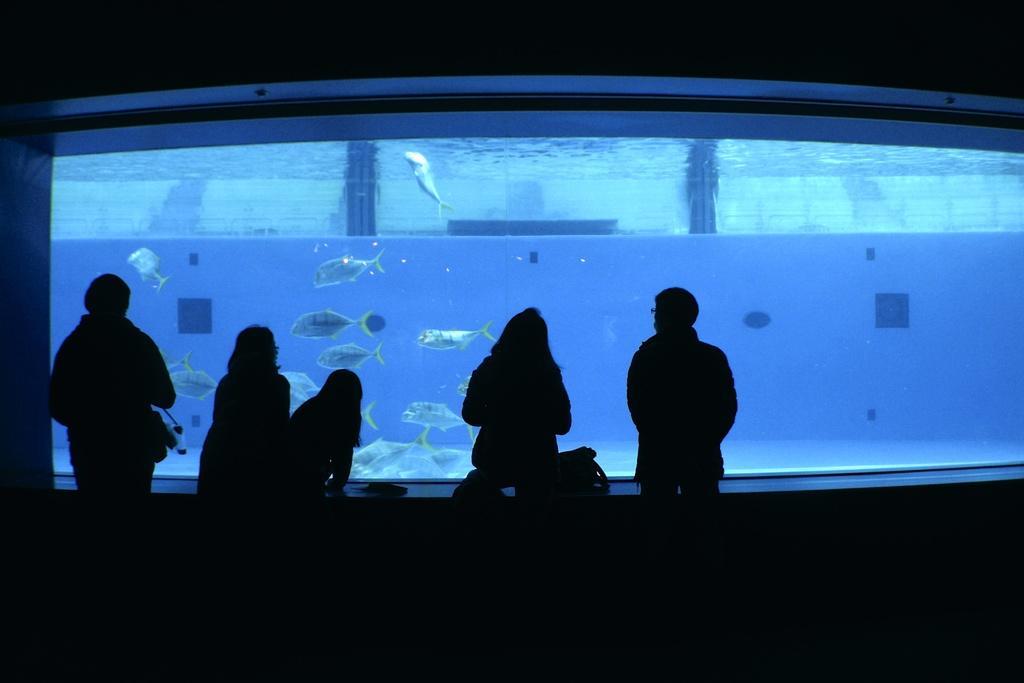Describe this image in one or two sentences. In this picture there are few persons standing in front of an aquarium which has few fishes in it. 